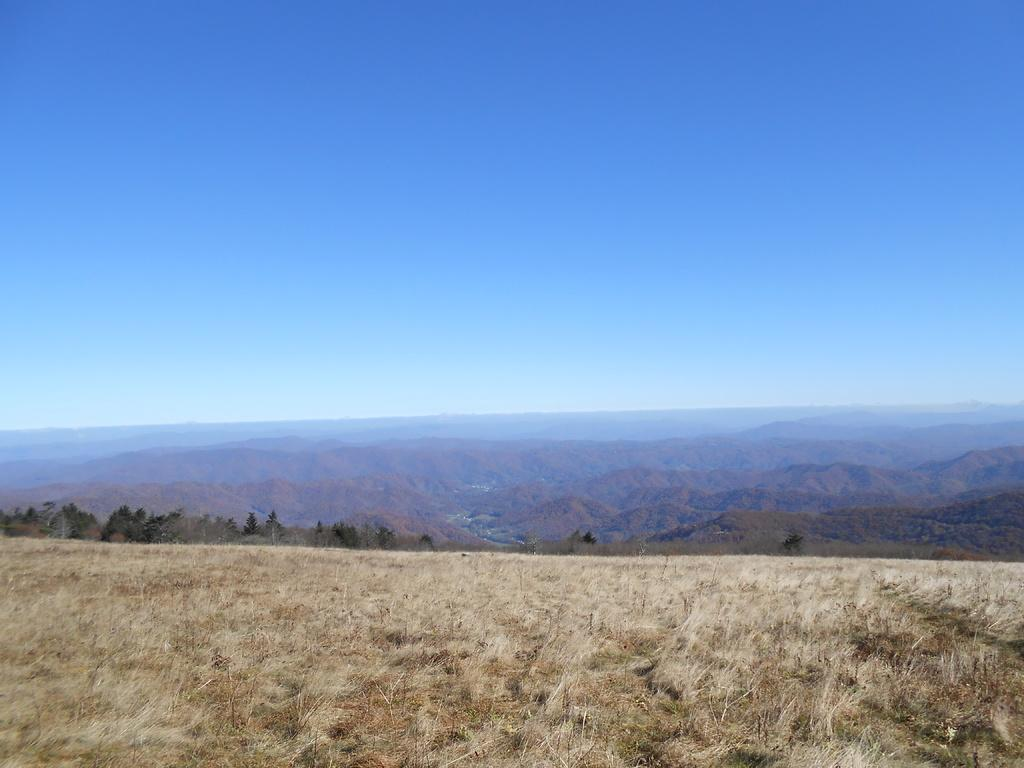What type of vegetation can be seen in the image? There are trees in the image. What geographical feature is visible in the background? There are mountains in the image. What is visible at the top of the image? The sky is visible at the top of the image. What type of ground cover is present at the bottom of the image? Grass is present at the bottom of the image. How many hands are visible in the image? There are no hands present in the image. What type of plant is growing near the trees in the image? There is no specific plant mentioned in the image; it only states that there are trees present. How many rabbits can be seen hopping around in the image? There are no rabbits present in the image. 